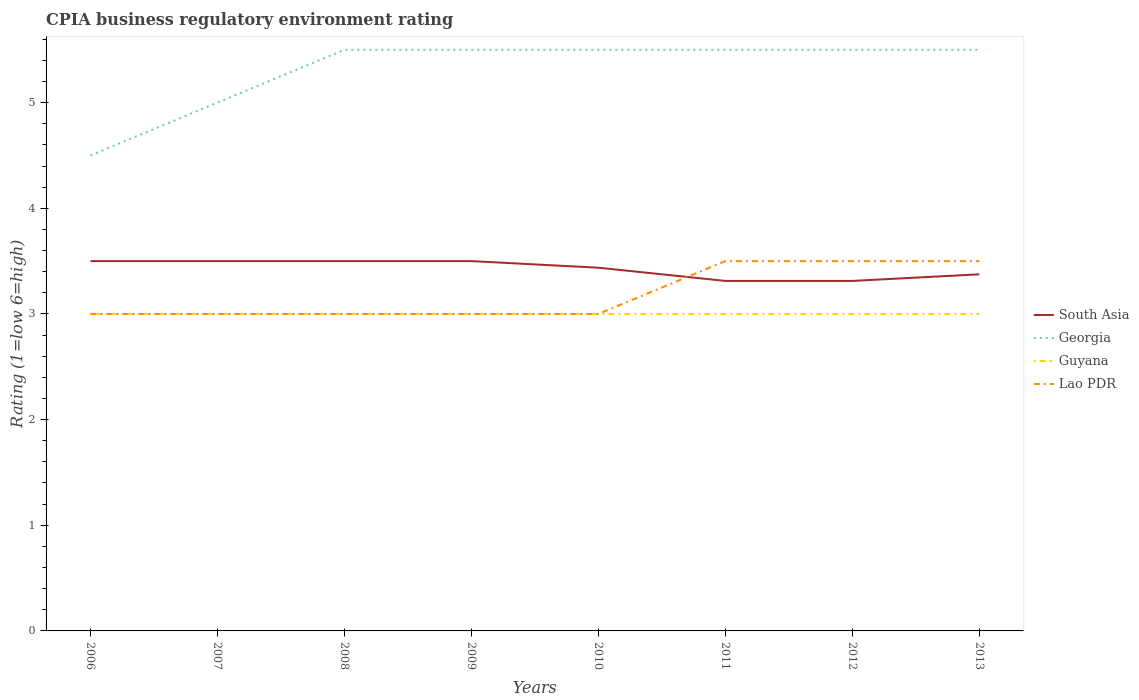How many different coloured lines are there?
Your answer should be very brief. 4. Is the number of lines equal to the number of legend labels?
Give a very brief answer. Yes. Across all years, what is the maximum CPIA rating in South Asia?
Keep it short and to the point. 3.31. In which year was the CPIA rating in Guyana maximum?
Ensure brevity in your answer.  2006. What is the total CPIA rating in Georgia in the graph?
Your answer should be very brief. -1. What is the difference between the highest and the second highest CPIA rating in South Asia?
Offer a very short reply. 0.19. Are the values on the major ticks of Y-axis written in scientific E-notation?
Offer a very short reply. No. Does the graph contain grids?
Offer a terse response. No. Where does the legend appear in the graph?
Give a very brief answer. Center right. How are the legend labels stacked?
Offer a terse response. Vertical. What is the title of the graph?
Offer a very short reply. CPIA business regulatory environment rating. Does "Small states" appear as one of the legend labels in the graph?
Keep it short and to the point. No. What is the label or title of the X-axis?
Provide a short and direct response. Years. What is the Rating (1=low 6=high) of South Asia in 2006?
Make the answer very short. 3.5. What is the Rating (1=low 6=high) of Lao PDR in 2006?
Provide a succinct answer. 3. What is the Rating (1=low 6=high) in South Asia in 2007?
Offer a terse response. 3.5. What is the Rating (1=low 6=high) in Georgia in 2007?
Provide a succinct answer. 5. What is the Rating (1=low 6=high) in Lao PDR in 2007?
Provide a succinct answer. 3. What is the Rating (1=low 6=high) of Georgia in 2008?
Provide a short and direct response. 5.5. What is the Rating (1=low 6=high) in Guyana in 2008?
Your response must be concise. 3. What is the Rating (1=low 6=high) in Lao PDR in 2008?
Keep it short and to the point. 3. What is the Rating (1=low 6=high) in Georgia in 2009?
Make the answer very short. 5.5. What is the Rating (1=low 6=high) of Guyana in 2009?
Keep it short and to the point. 3. What is the Rating (1=low 6=high) of Lao PDR in 2009?
Your answer should be very brief. 3. What is the Rating (1=low 6=high) in South Asia in 2010?
Your answer should be compact. 3.44. What is the Rating (1=low 6=high) in Lao PDR in 2010?
Your response must be concise. 3. What is the Rating (1=low 6=high) in South Asia in 2011?
Your answer should be compact. 3.31. What is the Rating (1=low 6=high) in Georgia in 2011?
Keep it short and to the point. 5.5. What is the Rating (1=low 6=high) of Lao PDR in 2011?
Give a very brief answer. 3.5. What is the Rating (1=low 6=high) in South Asia in 2012?
Offer a very short reply. 3.31. What is the Rating (1=low 6=high) of Lao PDR in 2012?
Keep it short and to the point. 3.5. What is the Rating (1=low 6=high) of South Asia in 2013?
Your answer should be compact. 3.38. What is the Rating (1=low 6=high) in Georgia in 2013?
Keep it short and to the point. 5.5. What is the Rating (1=low 6=high) in Guyana in 2013?
Provide a succinct answer. 3. What is the Rating (1=low 6=high) of Lao PDR in 2013?
Ensure brevity in your answer.  3.5. Across all years, what is the maximum Rating (1=low 6=high) in Guyana?
Your answer should be very brief. 3. Across all years, what is the minimum Rating (1=low 6=high) of South Asia?
Your answer should be very brief. 3.31. Across all years, what is the minimum Rating (1=low 6=high) of Georgia?
Offer a terse response. 4.5. What is the total Rating (1=low 6=high) of South Asia in the graph?
Make the answer very short. 27.44. What is the total Rating (1=low 6=high) in Georgia in the graph?
Make the answer very short. 42.5. What is the total Rating (1=low 6=high) in Guyana in the graph?
Provide a short and direct response. 24. What is the difference between the Rating (1=low 6=high) of South Asia in 2006 and that in 2007?
Offer a terse response. 0. What is the difference between the Rating (1=low 6=high) in Georgia in 2006 and that in 2007?
Make the answer very short. -0.5. What is the difference between the Rating (1=low 6=high) of Guyana in 2006 and that in 2007?
Your answer should be compact. 0. What is the difference between the Rating (1=low 6=high) in Lao PDR in 2006 and that in 2007?
Make the answer very short. 0. What is the difference between the Rating (1=low 6=high) in South Asia in 2006 and that in 2008?
Provide a short and direct response. 0. What is the difference between the Rating (1=low 6=high) in Georgia in 2006 and that in 2008?
Your answer should be very brief. -1. What is the difference between the Rating (1=low 6=high) in Guyana in 2006 and that in 2008?
Provide a succinct answer. 0. What is the difference between the Rating (1=low 6=high) of South Asia in 2006 and that in 2009?
Keep it short and to the point. 0. What is the difference between the Rating (1=low 6=high) in Guyana in 2006 and that in 2009?
Give a very brief answer. 0. What is the difference between the Rating (1=low 6=high) in Lao PDR in 2006 and that in 2009?
Provide a short and direct response. 0. What is the difference between the Rating (1=low 6=high) in South Asia in 2006 and that in 2010?
Provide a succinct answer. 0.06. What is the difference between the Rating (1=low 6=high) of Guyana in 2006 and that in 2010?
Provide a short and direct response. 0. What is the difference between the Rating (1=low 6=high) of South Asia in 2006 and that in 2011?
Give a very brief answer. 0.19. What is the difference between the Rating (1=low 6=high) in Georgia in 2006 and that in 2011?
Provide a short and direct response. -1. What is the difference between the Rating (1=low 6=high) of Lao PDR in 2006 and that in 2011?
Your response must be concise. -0.5. What is the difference between the Rating (1=low 6=high) of South Asia in 2006 and that in 2012?
Provide a short and direct response. 0.19. What is the difference between the Rating (1=low 6=high) in Guyana in 2006 and that in 2012?
Ensure brevity in your answer.  0. What is the difference between the Rating (1=low 6=high) in Georgia in 2006 and that in 2013?
Ensure brevity in your answer.  -1. What is the difference between the Rating (1=low 6=high) of Guyana in 2006 and that in 2013?
Your response must be concise. 0. What is the difference between the Rating (1=low 6=high) of Georgia in 2007 and that in 2008?
Provide a succinct answer. -0.5. What is the difference between the Rating (1=low 6=high) in Guyana in 2007 and that in 2008?
Your response must be concise. 0. What is the difference between the Rating (1=low 6=high) of South Asia in 2007 and that in 2009?
Provide a short and direct response. 0. What is the difference between the Rating (1=low 6=high) in South Asia in 2007 and that in 2010?
Your answer should be compact. 0.06. What is the difference between the Rating (1=low 6=high) of Georgia in 2007 and that in 2010?
Give a very brief answer. -0.5. What is the difference between the Rating (1=low 6=high) in Guyana in 2007 and that in 2010?
Offer a very short reply. 0. What is the difference between the Rating (1=low 6=high) of Lao PDR in 2007 and that in 2010?
Provide a short and direct response. 0. What is the difference between the Rating (1=low 6=high) of South Asia in 2007 and that in 2011?
Provide a short and direct response. 0.19. What is the difference between the Rating (1=low 6=high) of Georgia in 2007 and that in 2011?
Your answer should be compact. -0.5. What is the difference between the Rating (1=low 6=high) in Lao PDR in 2007 and that in 2011?
Keep it short and to the point. -0.5. What is the difference between the Rating (1=low 6=high) of South Asia in 2007 and that in 2012?
Your answer should be compact. 0.19. What is the difference between the Rating (1=low 6=high) of Georgia in 2007 and that in 2012?
Your answer should be very brief. -0.5. What is the difference between the Rating (1=low 6=high) in Guyana in 2007 and that in 2012?
Your answer should be very brief. 0. What is the difference between the Rating (1=low 6=high) of Georgia in 2007 and that in 2013?
Make the answer very short. -0.5. What is the difference between the Rating (1=low 6=high) of Lao PDR in 2007 and that in 2013?
Your answer should be very brief. -0.5. What is the difference between the Rating (1=low 6=high) of South Asia in 2008 and that in 2009?
Give a very brief answer. 0. What is the difference between the Rating (1=low 6=high) of Lao PDR in 2008 and that in 2009?
Provide a succinct answer. 0. What is the difference between the Rating (1=low 6=high) in South Asia in 2008 and that in 2010?
Offer a terse response. 0.06. What is the difference between the Rating (1=low 6=high) of Lao PDR in 2008 and that in 2010?
Your answer should be compact. 0. What is the difference between the Rating (1=low 6=high) of South Asia in 2008 and that in 2011?
Offer a very short reply. 0.19. What is the difference between the Rating (1=low 6=high) in Georgia in 2008 and that in 2011?
Offer a terse response. 0. What is the difference between the Rating (1=low 6=high) in Lao PDR in 2008 and that in 2011?
Make the answer very short. -0.5. What is the difference between the Rating (1=low 6=high) of South Asia in 2008 and that in 2012?
Give a very brief answer. 0.19. What is the difference between the Rating (1=low 6=high) in Lao PDR in 2008 and that in 2012?
Give a very brief answer. -0.5. What is the difference between the Rating (1=low 6=high) in Georgia in 2008 and that in 2013?
Offer a terse response. 0. What is the difference between the Rating (1=low 6=high) of Guyana in 2008 and that in 2013?
Keep it short and to the point. 0. What is the difference between the Rating (1=low 6=high) of Lao PDR in 2008 and that in 2013?
Offer a very short reply. -0.5. What is the difference between the Rating (1=low 6=high) of South Asia in 2009 and that in 2010?
Provide a short and direct response. 0.06. What is the difference between the Rating (1=low 6=high) in Georgia in 2009 and that in 2010?
Your response must be concise. 0. What is the difference between the Rating (1=low 6=high) in Guyana in 2009 and that in 2010?
Offer a very short reply. 0. What is the difference between the Rating (1=low 6=high) of Lao PDR in 2009 and that in 2010?
Provide a succinct answer. 0. What is the difference between the Rating (1=low 6=high) in South Asia in 2009 and that in 2011?
Give a very brief answer. 0.19. What is the difference between the Rating (1=low 6=high) in Georgia in 2009 and that in 2011?
Provide a short and direct response. 0. What is the difference between the Rating (1=low 6=high) in Guyana in 2009 and that in 2011?
Your response must be concise. 0. What is the difference between the Rating (1=low 6=high) of South Asia in 2009 and that in 2012?
Make the answer very short. 0.19. What is the difference between the Rating (1=low 6=high) of Guyana in 2009 and that in 2012?
Your response must be concise. 0. What is the difference between the Rating (1=low 6=high) of Lao PDR in 2009 and that in 2012?
Your response must be concise. -0.5. What is the difference between the Rating (1=low 6=high) of South Asia in 2009 and that in 2013?
Offer a very short reply. 0.12. What is the difference between the Rating (1=low 6=high) in Georgia in 2009 and that in 2013?
Keep it short and to the point. 0. What is the difference between the Rating (1=low 6=high) of Georgia in 2010 and that in 2011?
Offer a very short reply. 0. What is the difference between the Rating (1=low 6=high) in Guyana in 2010 and that in 2011?
Offer a terse response. 0. What is the difference between the Rating (1=low 6=high) of South Asia in 2010 and that in 2012?
Provide a short and direct response. 0.12. What is the difference between the Rating (1=low 6=high) in Georgia in 2010 and that in 2012?
Give a very brief answer. 0. What is the difference between the Rating (1=low 6=high) in Lao PDR in 2010 and that in 2012?
Provide a short and direct response. -0.5. What is the difference between the Rating (1=low 6=high) in South Asia in 2010 and that in 2013?
Keep it short and to the point. 0.06. What is the difference between the Rating (1=low 6=high) of Lao PDR in 2010 and that in 2013?
Make the answer very short. -0.5. What is the difference between the Rating (1=low 6=high) in Georgia in 2011 and that in 2012?
Your answer should be very brief. 0. What is the difference between the Rating (1=low 6=high) of Guyana in 2011 and that in 2012?
Offer a very short reply. 0. What is the difference between the Rating (1=low 6=high) in Lao PDR in 2011 and that in 2012?
Make the answer very short. 0. What is the difference between the Rating (1=low 6=high) of South Asia in 2011 and that in 2013?
Keep it short and to the point. -0.06. What is the difference between the Rating (1=low 6=high) in Lao PDR in 2011 and that in 2013?
Your response must be concise. 0. What is the difference between the Rating (1=low 6=high) of South Asia in 2012 and that in 2013?
Offer a terse response. -0.06. What is the difference between the Rating (1=low 6=high) of South Asia in 2006 and the Rating (1=low 6=high) of Georgia in 2007?
Ensure brevity in your answer.  -1.5. What is the difference between the Rating (1=low 6=high) of South Asia in 2006 and the Rating (1=low 6=high) of Guyana in 2007?
Ensure brevity in your answer.  0.5. What is the difference between the Rating (1=low 6=high) in Georgia in 2006 and the Rating (1=low 6=high) in Guyana in 2007?
Your answer should be very brief. 1.5. What is the difference between the Rating (1=low 6=high) in Georgia in 2006 and the Rating (1=low 6=high) in Lao PDR in 2007?
Provide a short and direct response. 1.5. What is the difference between the Rating (1=low 6=high) of South Asia in 2006 and the Rating (1=low 6=high) of Guyana in 2008?
Your answer should be compact. 0.5. What is the difference between the Rating (1=low 6=high) of South Asia in 2006 and the Rating (1=low 6=high) of Lao PDR in 2008?
Offer a very short reply. 0.5. What is the difference between the Rating (1=low 6=high) in Guyana in 2006 and the Rating (1=low 6=high) in Lao PDR in 2008?
Provide a succinct answer. 0. What is the difference between the Rating (1=low 6=high) of South Asia in 2006 and the Rating (1=low 6=high) of Georgia in 2010?
Offer a terse response. -2. What is the difference between the Rating (1=low 6=high) of Georgia in 2006 and the Rating (1=low 6=high) of Lao PDR in 2010?
Offer a terse response. 1.5. What is the difference between the Rating (1=low 6=high) in Guyana in 2006 and the Rating (1=low 6=high) in Lao PDR in 2010?
Provide a succinct answer. 0. What is the difference between the Rating (1=low 6=high) in Georgia in 2006 and the Rating (1=low 6=high) in Lao PDR in 2011?
Offer a very short reply. 1. What is the difference between the Rating (1=low 6=high) of Guyana in 2006 and the Rating (1=low 6=high) of Lao PDR in 2011?
Provide a short and direct response. -0.5. What is the difference between the Rating (1=low 6=high) of South Asia in 2006 and the Rating (1=low 6=high) of Georgia in 2012?
Offer a terse response. -2. What is the difference between the Rating (1=low 6=high) in South Asia in 2006 and the Rating (1=low 6=high) in Guyana in 2012?
Provide a succinct answer. 0.5. What is the difference between the Rating (1=low 6=high) in Georgia in 2006 and the Rating (1=low 6=high) in Guyana in 2012?
Provide a short and direct response. 1.5. What is the difference between the Rating (1=low 6=high) in Georgia in 2006 and the Rating (1=low 6=high) in Lao PDR in 2012?
Your response must be concise. 1. What is the difference between the Rating (1=low 6=high) in South Asia in 2006 and the Rating (1=low 6=high) in Guyana in 2013?
Offer a terse response. 0.5. What is the difference between the Rating (1=low 6=high) in South Asia in 2006 and the Rating (1=low 6=high) in Lao PDR in 2013?
Your response must be concise. 0. What is the difference between the Rating (1=low 6=high) of Guyana in 2006 and the Rating (1=low 6=high) of Lao PDR in 2013?
Provide a short and direct response. -0.5. What is the difference between the Rating (1=low 6=high) of South Asia in 2007 and the Rating (1=low 6=high) of Guyana in 2008?
Keep it short and to the point. 0.5. What is the difference between the Rating (1=low 6=high) of South Asia in 2007 and the Rating (1=low 6=high) of Lao PDR in 2008?
Offer a terse response. 0.5. What is the difference between the Rating (1=low 6=high) of Georgia in 2007 and the Rating (1=low 6=high) of Guyana in 2008?
Offer a terse response. 2. What is the difference between the Rating (1=low 6=high) of Georgia in 2007 and the Rating (1=low 6=high) of Lao PDR in 2008?
Provide a succinct answer. 2. What is the difference between the Rating (1=low 6=high) in Guyana in 2007 and the Rating (1=low 6=high) in Lao PDR in 2008?
Provide a short and direct response. 0. What is the difference between the Rating (1=low 6=high) in South Asia in 2007 and the Rating (1=low 6=high) in Lao PDR in 2009?
Your answer should be compact. 0.5. What is the difference between the Rating (1=low 6=high) of Georgia in 2007 and the Rating (1=low 6=high) of Guyana in 2009?
Provide a succinct answer. 2. What is the difference between the Rating (1=low 6=high) of Georgia in 2007 and the Rating (1=low 6=high) of Lao PDR in 2009?
Your answer should be very brief. 2. What is the difference between the Rating (1=low 6=high) in Georgia in 2007 and the Rating (1=low 6=high) in Guyana in 2010?
Offer a very short reply. 2. What is the difference between the Rating (1=low 6=high) of Georgia in 2007 and the Rating (1=low 6=high) of Lao PDR in 2010?
Provide a short and direct response. 2. What is the difference between the Rating (1=low 6=high) in Guyana in 2007 and the Rating (1=low 6=high) in Lao PDR in 2010?
Your answer should be compact. 0. What is the difference between the Rating (1=low 6=high) in South Asia in 2007 and the Rating (1=low 6=high) in Georgia in 2011?
Keep it short and to the point. -2. What is the difference between the Rating (1=low 6=high) in Georgia in 2007 and the Rating (1=low 6=high) in Guyana in 2011?
Make the answer very short. 2. What is the difference between the Rating (1=low 6=high) in Guyana in 2007 and the Rating (1=low 6=high) in Lao PDR in 2011?
Provide a short and direct response. -0.5. What is the difference between the Rating (1=low 6=high) of South Asia in 2007 and the Rating (1=low 6=high) of Georgia in 2012?
Make the answer very short. -2. What is the difference between the Rating (1=low 6=high) in South Asia in 2007 and the Rating (1=low 6=high) in Lao PDR in 2012?
Offer a terse response. 0. What is the difference between the Rating (1=low 6=high) in South Asia in 2007 and the Rating (1=low 6=high) in Georgia in 2013?
Your answer should be compact. -2. What is the difference between the Rating (1=low 6=high) in South Asia in 2007 and the Rating (1=low 6=high) in Lao PDR in 2013?
Your answer should be very brief. 0. What is the difference between the Rating (1=low 6=high) of Georgia in 2007 and the Rating (1=low 6=high) of Lao PDR in 2013?
Your response must be concise. 1.5. What is the difference between the Rating (1=low 6=high) of Guyana in 2007 and the Rating (1=low 6=high) of Lao PDR in 2013?
Ensure brevity in your answer.  -0.5. What is the difference between the Rating (1=low 6=high) of South Asia in 2008 and the Rating (1=low 6=high) of Guyana in 2009?
Your answer should be very brief. 0.5. What is the difference between the Rating (1=low 6=high) of South Asia in 2008 and the Rating (1=low 6=high) of Lao PDR in 2009?
Give a very brief answer. 0.5. What is the difference between the Rating (1=low 6=high) of Georgia in 2008 and the Rating (1=low 6=high) of Guyana in 2009?
Offer a very short reply. 2.5. What is the difference between the Rating (1=low 6=high) in Georgia in 2008 and the Rating (1=low 6=high) in Lao PDR in 2009?
Your answer should be very brief. 2.5. What is the difference between the Rating (1=low 6=high) of Guyana in 2008 and the Rating (1=low 6=high) of Lao PDR in 2009?
Offer a terse response. 0. What is the difference between the Rating (1=low 6=high) of South Asia in 2008 and the Rating (1=low 6=high) of Georgia in 2010?
Your answer should be compact. -2. What is the difference between the Rating (1=low 6=high) in South Asia in 2008 and the Rating (1=low 6=high) in Lao PDR in 2010?
Provide a succinct answer. 0.5. What is the difference between the Rating (1=low 6=high) of South Asia in 2008 and the Rating (1=low 6=high) of Lao PDR in 2011?
Provide a short and direct response. 0. What is the difference between the Rating (1=low 6=high) in South Asia in 2008 and the Rating (1=low 6=high) in Georgia in 2012?
Ensure brevity in your answer.  -2. What is the difference between the Rating (1=low 6=high) in South Asia in 2008 and the Rating (1=low 6=high) in Guyana in 2012?
Keep it short and to the point. 0.5. What is the difference between the Rating (1=low 6=high) of Georgia in 2008 and the Rating (1=low 6=high) of Lao PDR in 2012?
Provide a short and direct response. 2. What is the difference between the Rating (1=low 6=high) of South Asia in 2008 and the Rating (1=low 6=high) of Guyana in 2013?
Your answer should be compact. 0.5. What is the difference between the Rating (1=low 6=high) in Georgia in 2008 and the Rating (1=low 6=high) in Guyana in 2013?
Your answer should be compact. 2.5. What is the difference between the Rating (1=low 6=high) of South Asia in 2009 and the Rating (1=low 6=high) of Georgia in 2010?
Keep it short and to the point. -2. What is the difference between the Rating (1=low 6=high) in South Asia in 2009 and the Rating (1=low 6=high) in Lao PDR in 2010?
Provide a succinct answer. 0.5. What is the difference between the Rating (1=low 6=high) of South Asia in 2009 and the Rating (1=low 6=high) of Georgia in 2011?
Ensure brevity in your answer.  -2. What is the difference between the Rating (1=low 6=high) in South Asia in 2009 and the Rating (1=low 6=high) in Guyana in 2011?
Keep it short and to the point. 0.5. What is the difference between the Rating (1=low 6=high) in Georgia in 2009 and the Rating (1=low 6=high) in Lao PDR in 2011?
Offer a very short reply. 2. What is the difference between the Rating (1=low 6=high) in South Asia in 2009 and the Rating (1=low 6=high) in Georgia in 2012?
Your answer should be compact. -2. What is the difference between the Rating (1=low 6=high) in Georgia in 2009 and the Rating (1=low 6=high) in Lao PDR in 2012?
Offer a terse response. 2. What is the difference between the Rating (1=low 6=high) of South Asia in 2009 and the Rating (1=low 6=high) of Georgia in 2013?
Give a very brief answer. -2. What is the difference between the Rating (1=low 6=high) in South Asia in 2009 and the Rating (1=low 6=high) in Lao PDR in 2013?
Give a very brief answer. 0. What is the difference between the Rating (1=low 6=high) in Guyana in 2009 and the Rating (1=low 6=high) in Lao PDR in 2013?
Give a very brief answer. -0.5. What is the difference between the Rating (1=low 6=high) in South Asia in 2010 and the Rating (1=low 6=high) in Georgia in 2011?
Provide a short and direct response. -2.06. What is the difference between the Rating (1=low 6=high) in South Asia in 2010 and the Rating (1=low 6=high) in Guyana in 2011?
Your answer should be very brief. 0.44. What is the difference between the Rating (1=low 6=high) of South Asia in 2010 and the Rating (1=low 6=high) of Lao PDR in 2011?
Your answer should be compact. -0.06. What is the difference between the Rating (1=low 6=high) of Georgia in 2010 and the Rating (1=low 6=high) of Guyana in 2011?
Provide a short and direct response. 2.5. What is the difference between the Rating (1=low 6=high) of Guyana in 2010 and the Rating (1=low 6=high) of Lao PDR in 2011?
Offer a very short reply. -0.5. What is the difference between the Rating (1=low 6=high) in South Asia in 2010 and the Rating (1=low 6=high) in Georgia in 2012?
Give a very brief answer. -2.06. What is the difference between the Rating (1=low 6=high) in South Asia in 2010 and the Rating (1=low 6=high) in Guyana in 2012?
Keep it short and to the point. 0.44. What is the difference between the Rating (1=low 6=high) of South Asia in 2010 and the Rating (1=low 6=high) of Lao PDR in 2012?
Your response must be concise. -0.06. What is the difference between the Rating (1=low 6=high) in Georgia in 2010 and the Rating (1=low 6=high) in Guyana in 2012?
Offer a terse response. 2.5. What is the difference between the Rating (1=low 6=high) in Georgia in 2010 and the Rating (1=low 6=high) in Lao PDR in 2012?
Make the answer very short. 2. What is the difference between the Rating (1=low 6=high) of Guyana in 2010 and the Rating (1=low 6=high) of Lao PDR in 2012?
Ensure brevity in your answer.  -0.5. What is the difference between the Rating (1=low 6=high) in South Asia in 2010 and the Rating (1=low 6=high) in Georgia in 2013?
Give a very brief answer. -2.06. What is the difference between the Rating (1=low 6=high) of South Asia in 2010 and the Rating (1=low 6=high) of Guyana in 2013?
Give a very brief answer. 0.44. What is the difference between the Rating (1=low 6=high) in South Asia in 2010 and the Rating (1=low 6=high) in Lao PDR in 2013?
Your answer should be compact. -0.06. What is the difference between the Rating (1=low 6=high) of Guyana in 2010 and the Rating (1=low 6=high) of Lao PDR in 2013?
Make the answer very short. -0.5. What is the difference between the Rating (1=low 6=high) in South Asia in 2011 and the Rating (1=low 6=high) in Georgia in 2012?
Offer a very short reply. -2.19. What is the difference between the Rating (1=low 6=high) in South Asia in 2011 and the Rating (1=low 6=high) in Guyana in 2012?
Provide a succinct answer. 0.31. What is the difference between the Rating (1=low 6=high) of South Asia in 2011 and the Rating (1=low 6=high) of Lao PDR in 2012?
Keep it short and to the point. -0.19. What is the difference between the Rating (1=low 6=high) of Georgia in 2011 and the Rating (1=low 6=high) of Guyana in 2012?
Offer a terse response. 2.5. What is the difference between the Rating (1=low 6=high) in Guyana in 2011 and the Rating (1=low 6=high) in Lao PDR in 2012?
Offer a terse response. -0.5. What is the difference between the Rating (1=low 6=high) of South Asia in 2011 and the Rating (1=low 6=high) of Georgia in 2013?
Make the answer very short. -2.19. What is the difference between the Rating (1=low 6=high) of South Asia in 2011 and the Rating (1=low 6=high) of Guyana in 2013?
Make the answer very short. 0.31. What is the difference between the Rating (1=low 6=high) of South Asia in 2011 and the Rating (1=low 6=high) of Lao PDR in 2013?
Give a very brief answer. -0.19. What is the difference between the Rating (1=low 6=high) of Georgia in 2011 and the Rating (1=low 6=high) of Guyana in 2013?
Give a very brief answer. 2.5. What is the difference between the Rating (1=low 6=high) of Guyana in 2011 and the Rating (1=low 6=high) of Lao PDR in 2013?
Your answer should be compact. -0.5. What is the difference between the Rating (1=low 6=high) in South Asia in 2012 and the Rating (1=low 6=high) in Georgia in 2013?
Make the answer very short. -2.19. What is the difference between the Rating (1=low 6=high) in South Asia in 2012 and the Rating (1=low 6=high) in Guyana in 2013?
Make the answer very short. 0.31. What is the difference between the Rating (1=low 6=high) of South Asia in 2012 and the Rating (1=low 6=high) of Lao PDR in 2013?
Keep it short and to the point. -0.19. What is the difference between the Rating (1=low 6=high) of Georgia in 2012 and the Rating (1=low 6=high) of Guyana in 2013?
Provide a succinct answer. 2.5. What is the difference between the Rating (1=low 6=high) in Guyana in 2012 and the Rating (1=low 6=high) in Lao PDR in 2013?
Ensure brevity in your answer.  -0.5. What is the average Rating (1=low 6=high) in South Asia per year?
Ensure brevity in your answer.  3.43. What is the average Rating (1=low 6=high) in Georgia per year?
Provide a short and direct response. 5.31. What is the average Rating (1=low 6=high) of Lao PDR per year?
Give a very brief answer. 3.19. In the year 2006, what is the difference between the Rating (1=low 6=high) of Georgia and Rating (1=low 6=high) of Lao PDR?
Keep it short and to the point. 1.5. In the year 2006, what is the difference between the Rating (1=low 6=high) in Guyana and Rating (1=low 6=high) in Lao PDR?
Your response must be concise. 0. In the year 2007, what is the difference between the Rating (1=low 6=high) in South Asia and Rating (1=low 6=high) in Georgia?
Your answer should be compact. -1.5. In the year 2007, what is the difference between the Rating (1=low 6=high) in South Asia and Rating (1=low 6=high) in Guyana?
Keep it short and to the point. 0.5. In the year 2007, what is the difference between the Rating (1=low 6=high) in South Asia and Rating (1=low 6=high) in Lao PDR?
Ensure brevity in your answer.  0.5. In the year 2007, what is the difference between the Rating (1=low 6=high) of Georgia and Rating (1=low 6=high) of Lao PDR?
Offer a terse response. 2. In the year 2007, what is the difference between the Rating (1=low 6=high) in Guyana and Rating (1=low 6=high) in Lao PDR?
Give a very brief answer. 0. In the year 2008, what is the difference between the Rating (1=low 6=high) of South Asia and Rating (1=low 6=high) of Guyana?
Your response must be concise. 0.5. In the year 2008, what is the difference between the Rating (1=low 6=high) of South Asia and Rating (1=low 6=high) of Lao PDR?
Provide a succinct answer. 0.5. In the year 2008, what is the difference between the Rating (1=low 6=high) of Georgia and Rating (1=low 6=high) of Guyana?
Offer a very short reply. 2.5. In the year 2008, what is the difference between the Rating (1=low 6=high) in Guyana and Rating (1=low 6=high) in Lao PDR?
Offer a terse response. 0. In the year 2009, what is the difference between the Rating (1=low 6=high) in South Asia and Rating (1=low 6=high) in Georgia?
Make the answer very short. -2. In the year 2009, what is the difference between the Rating (1=low 6=high) of South Asia and Rating (1=low 6=high) of Lao PDR?
Offer a terse response. 0.5. In the year 2009, what is the difference between the Rating (1=low 6=high) of Georgia and Rating (1=low 6=high) of Guyana?
Your answer should be very brief. 2.5. In the year 2010, what is the difference between the Rating (1=low 6=high) of South Asia and Rating (1=low 6=high) of Georgia?
Your answer should be very brief. -2.06. In the year 2010, what is the difference between the Rating (1=low 6=high) of South Asia and Rating (1=low 6=high) of Guyana?
Provide a succinct answer. 0.44. In the year 2010, what is the difference between the Rating (1=low 6=high) of South Asia and Rating (1=low 6=high) of Lao PDR?
Give a very brief answer. 0.44. In the year 2010, what is the difference between the Rating (1=low 6=high) in Georgia and Rating (1=low 6=high) in Guyana?
Keep it short and to the point. 2.5. In the year 2010, what is the difference between the Rating (1=low 6=high) in Guyana and Rating (1=low 6=high) in Lao PDR?
Offer a terse response. 0. In the year 2011, what is the difference between the Rating (1=low 6=high) of South Asia and Rating (1=low 6=high) of Georgia?
Your answer should be compact. -2.19. In the year 2011, what is the difference between the Rating (1=low 6=high) in South Asia and Rating (1=low 6=high) in Guyana?
Your response must be concise. 0.31. In the year 2011, what is the difference between the Rating (1=low 6=high) in South Asia and Rating (1=low 6=high) in Lao PDR?
Give a very brief answer. -0.19. In the year 2011, what is the difference between the Rating (1=low 6=high) of Georgia and Rating (1=low 6=high) of Lao PDR?
Ensure brevity in your answer.  2. In the year 2012, what is the difference between the Rating (1=low 6=high) in South Asia and Rating (1=low 6=high) in Georgia?
Ensure brevity in your answer.  -2.19. In the year 2012, what is the difference between the Rating (1=low 6=high) in South Asia and Rating (1=low 6=high) in Guyana?
Offer a very short reply. 0.31. In the year 2012, what is the difference between the Rating (1=low 6=high) of South Asia and Rating (1=low 6=high) of Lao PDR?
Make the answer very short. -0.19. In the year 2013, what is the difference between the Rating (1=low 6=high) of South Asia and Rating (1=low 6=high) of Georgia?
Your answer should be compact. -2.12. In the year 2013, what is the difference between the Rating (1=low 6=high) in South Asia and Rating (1=low 6=high) in Lao PDR?
Provide a succinct answer. -0.12. In the year 2013, what is the difference between the Rating (1=low 6=high) in Georgia and Rating (1=low 6=high) in Guyana?
Your answer should be compact. 2.5. In the year 2013, what is the difference between the Rating (1=low 6=high) of Georgia and Rating (1=low 6=high) of Lao PDR?
Offer a terse response. 2. In the year 2013, what is the difference between the Rating (1=low 6=high) of Guyana and Rating (1=low 6=high) of Lao PDR?
Your answer should be very brief. -0.5. What is the ratio of the Rating (1=low 6=high) in South Asia in 2006 to that in 2007?
Give a very brief answer. 1. What is the ratio of the Rating (1=low 6=high) in Georgia in 2006 to that in 2007?
Your response must be concise. 0.9. What is the ratio of the Rating (1=low 6=high) of Guyana in 2006 to that in 2007?
Your response must be concise. 1. What is the ratio of the Rating (1=low 6=high) in Georgia in 2006 to that in 2008?
Give a very brief answer. 0.82. What is the ratio of the Rating (1=low 6=high) of South Asia in 2006 to that in 2009?
Provide a short and direct response. 1. What is the ratio of the Rating (1=low 6=high) of Georgia in 2006 to that in 2009?
Your answer should be very brief. 0.82. What is the ratio of the Rating (1=low 6=high) in Lao PDR in 2006 to that in 2009?
Provide a short and direct response. 1. What is the ratio of the Rating (1=low 6=high) of South Asia in 2006 to that in 2010?
Your response must be concise. 1.02. What is the ratio of the Rating (1=low 6=high) in Georgia in 2006 to that in 2010?
Offer a very short reply. 0.82. What is the ratio of the Rating (1=low 6=high) of South Asia in 2006 to that in 2011?
Provide a short and direct response. 1.06. What is the ratio of the Rating (1=low 6=high) in Georgia in 2006 to that in 2011?
Offer a terse response. 0.82. What is the ratio of the Rating (1=low 6=high) of South Asia in 2006 to that in 2012?
Make the answer very short. 1.06. What is the ratio of the Rating (1=low 6=high) in Georgia in 2006 to that in 2012?
Your answer should be compact. 0.82. What is the ratio of the Rating (1=low 6=high) of South Asia in 2006 to that in 2013?
Make the answer very short. 1.04. What is the ratio of the Rating (1=low 6=high) in Georgia in 2006 to that in 2013?
Your response must be concise. 0.82. What is the ratio of the Rating (1=low 6=high) in Lao PDR in 2006 to that in 2013?
Keep it short and to the point. 0.86. What is the ratio of the Rating (1=low 6=high) in Georgia in 2007 to that in 2008?
Offer a terse response. 0.91. What is the ratio of the Rating (1=low 6=high) of Guyana in 2007 to that in 2008?
Offer a terse response. 1. What is the ratio of the Rating (1=low 6=high) of Lao PDR in 2007 to that in 2008?
Provide a succinct answer. 1. What is the ratio of the Rating (1=low 6=high) in Georgia in 2007 to that in 2009?
Make the answer very short. 0.91. What is the ratio of the Rating (1=low 6=high) of Lao PDR in 2007 to that in 2009?
Ensure brevity in your answer.  1. What is the ratio of the Rating (1=low 6=high) of South Asia in 2007 to that in 2010?
Your answer should be compact. 1.02. What is the ratio of the Rating (1=low 6=high) in Guyana in 2007 to that in 2010?
Offer a terse response. 1. What is the ratio of the Rating (1=low 6=high) in Lao PDR in 2007 to that in 2010?
Make the answer very short. 1. What is the ratio of the Rating (1=low 6=high) of South Asia in 2007 to that in 2011?
Your answer should be compact. 1.06. What is the ratio of the Rating (1=low 6=high) of South Asia in 2007 to that in 2012?
Offer a terse response. 1.06. What is the ratio of the Rating (1=low 6=high) of Lao PDR in 2007 to that in 2012?
Ensure brevity in your answer.  0.86. What is the ratio of the Rating (1=low 6=high) in South Asia in 2007 to that in 2013?
Provide a short and direct response. 1.04. What is the ratio of the Rating (1=low 6=high) of Georgia in 2007 to that in 2013?
Your answer should be very brief. 0.91. What is the ratio of the Rating (1=low 6=high) in South Asia in 2008 to that in 2009?
Your response must be concise. 1. What is the ratio of the Rating (1=low 6=high) in Georgia in 2008 to that in 2009?
Offer a terse response. 1. What is the ratio of the Rating (1=low 6=high) in Guyana in 2008 to that in 2009?
Provide a short and direct response. 1. What is the ratio of the Rating (1=low 6=high) in South Asia in 2008 to that in 2010?
Give a very brief answer. 1.02. What is the ratio of the Rating (1=low 6=high) of Georgia in 2008 to that in 2010?
Make the answer very short. 1. What is the ratio of the Rating (1=low 6=high) in South Asia in 2008 to that in 2011?
Your answer should be very brief. 1.06. What is the ratio of the Rating (1=low 6=high) of Georgia in 2008 to that in 2011?
Your answer should be very brief. 1. What is the ratio of the Rating (1=low 6=high) of Guyana in 2008 to that in 2011?
Ensure brevity in your answer.  1. What is the ratio of the Rating (1=low 6=high) in South Asia in 2008 to that in 2012?
Provide a short and direct response. 1.06. What is the ratio of the Rating (1=low 6=high) in Georgia in 2008 to that in 2012?
Offer a very short reply. 1. What is the ratio of the Rating (1=low 6=high) of South Asia in 2008 to that in 2013?
Offer a terse response. 1.04. What is the ratio of the Rating (1=low 6=high) of Georgia in 2008 to that in 2013?
Give a very brief answer. 1. What is the ratio of the Rating (1=low 6=high) in Guyana in 2008 to that in 2013?
Provide a succinct answer. 1. What is the ratio of the Rating (1=low 6=high) in South Asia in 2009 to that in 2010?
Offer a very short reply. 1.02. What is the ratio of the Rating (1=low 6=high) of Georgia in 2009 to that in 2010?
Provide a short and direct response. 1. What is the ratio of the Rating (1=low 6=high) of South Asia in 2009 to that in 2011?
Your answer should be compact. 1.06. What is the ratio of the Rating (1=low 6=high) of Georgia in 2009 to that in 2011?
Offer a terse response. 1. What is the ratio of the Rating (1=low 6=high) of Guyana in 2009 to that in 2011?
Provide a short and direct response. 1. What is the ratio of the Rating (1=low 6=high) of Lao PDR in 2009 to that in 2011?
Keep it short and to the point. 0.86. What is the ratio of the Rating (1=low 6=high) in South Asia in 2009 to that in 2012?
Offer a terse response. 1.06. What is the ratio of the Rating (1=low 6=high) of Georgia in 2009 to that in 2012?
Ensure brevity in your answer.  1. What is the ratio of the Rating (1=low 6=high) of Guyana in 2009 to that in 2012?
Offer a terse response. 1. What is the ratio of the Rating (1=low 6=high) of Lao PDR in 2009 to that in 2012?
Your answer should be compact. 0.86. What is the ratio of the Rating (1=low 6=high) in South Asia in 2009 to that in 2013?
Make the answer very short. 1.04. What is the ratio of the Rating (1=low 6=high) of Guyana in 2009 to that in 2013?
Ensure brevity in your answer.  1. What is the ratio of the Rating (1=low 6=high) in Lao PDR in 2009 to that in 2013?
Your answer should be very brief. 0.86. What is the ratio of the Rating (1=low 6=high) of South Asia in 2010 to that in 2011?
Give a very brief answer. 1.04. What is the ratio of the Rating (1=low 6=high) of South Asia in 2010 to that in 2012?
Your response must be concise. 1.04. What is the ratio of the Rating (1=low 6=high) of Lao PDR in 2010 to that in 2012?
Offer a terse response. 0.86. What is the ratio of the Rating (1=low 6=high) in South Asia in 2010 to that in 2013?
Give a very brief answer. 1.02. What is the ratio of the Rating (1=low 6=high) of Guyana in 2011 to that in 2012?
Ensure brevity in your answer.  1. What is the ratio of the Rating (1=low 6=high) in Lao PDR in 2011 to that in 2012?
Ensure brevity in your answer.  1. What is the ratio of the Rating (1=low 6=high) in South Asia in 2011 to that in 2013?
Keep it short and to the point. 0.98. What is the ratio of the Rating (1=low 6=high) of Georgia in 2011 to that in 2013?
Offer a very short reply. 1. What is the ratio of the Rating (1=low 6=high) in Guyana in 2011 to that in 2013?
Your answer should be very brief. 1. What is the ratio of the Rating (1=low 6=high) of Lao PDR in 2011 to that in 2013?
Offer a terse response. 1. What is the ratio of the Rating (1=low 6=high) of South Asia in 2012 to that in 2013?
Make the answer very short. 0.98. What is the ratio of the Rating (1=low 6=high) of Georgia in 2012 to that in 2013?
Offer a very short reply. 1. What is the ratio of the Rating (1=low 6=high) of Lao PDR in 2012 to that in 2013?
Your answer should be very brief. 1. What is the difference between the highest and the second highest Rating (1=low 6=high) in Guyana?
Offer a terse response. 0. What is the difference between the highest and the lowest Rating (1=low 6=high) in South Asia?
Provide a succinct answer. 0.19. What is the difference between the highest and the lowest Rating (1=low 6=high) of Guyana?
Ensure brevity in your answer.  0. What is the difference between the highest and the lowest Rating (1=low 6=high) in Lao PDR?
Make the answer very short. 0.5. 